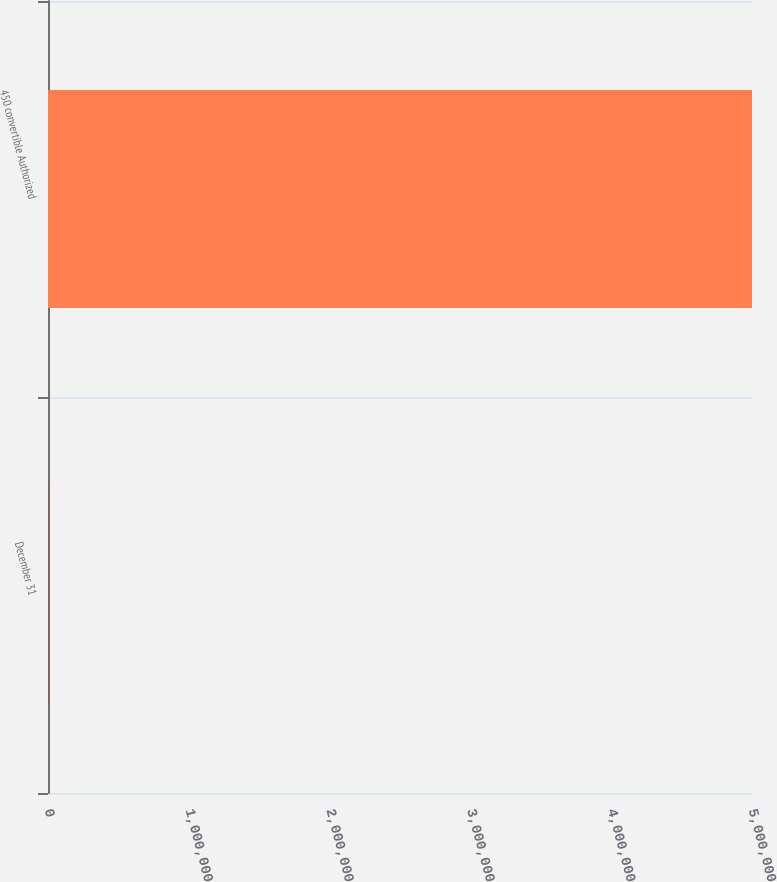<chart> <loc_0><loc_0><loc_500><loc_500><bar_chart><fcel>December 31<fcel>450 convertible Authorized<nl><fcel>2007<fcel>5e+06<nl></chart> 